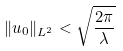Convert formula to latex. <formula><loc_0><loc_0><loc_500><loc_500>\| u _ { 0 } \| _ { L ^ { 2 } } < \sqrt { \frac { 2 \pi } { \lambda } }</formula> 